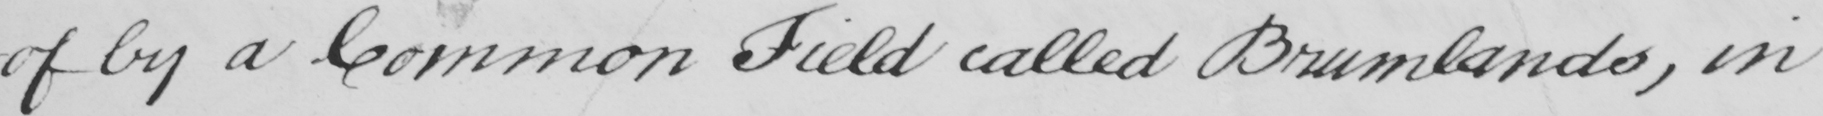Transcribe the text shown in this historical manuscript line. -of by a Common Field called Brumlands , in 